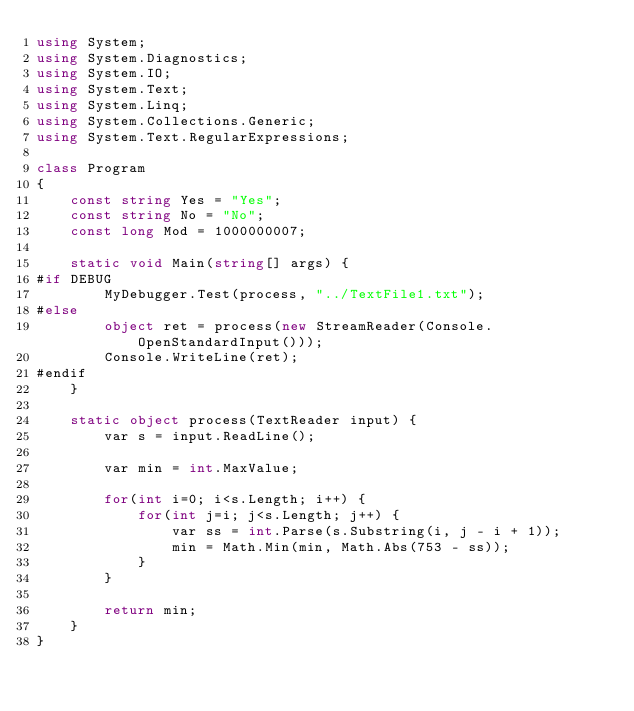<code> <loc_0><loc_0><loc_500><loc_500><_C#_>using System;
using System.Diagnostics;
using System.IO;
using System.Text;
using System.Linq;
using System.Collections.Generic;
using System.Text.RegularExpressions;

class Program
{
    const string Yes = "Yes";
    const string No = "No";
    const long Mod = 1000000007;

    static void Main(string[] args) {
#if DEBUG
        MyDebugger.Test(process, "../TextFile1.txt");
#else
        object ret = process(new StreamReader(Console.OpenStandardInput()));
        Console.WriteLine(ret);
#endif
    }

    static object process(TextReader input) {
        var s = input.ReadLine();

        var min = int.MaxValue;

        for(int i=0; i<s.Length; i++) {
            for(int j=i; j<s.Length; j++) {
                var ss = int.Parse(s.Substring(i, j - i + 1));
                min = Math.Min(min, Math.Abs(753 - ss));
            }
        }

        return min;
    }
}
</code> 